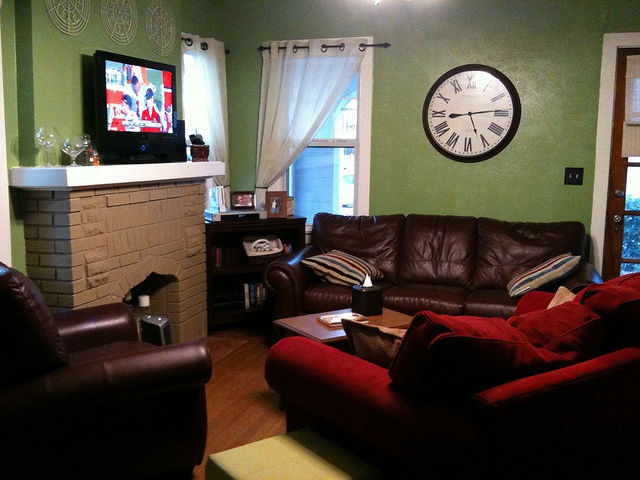Describe the objects in this image and their specific colors. I can see couch in gray, black, maroon, and brown tones, couch in gray, black, maroon, and brown tones, chair in gray, black, maroon, and brown tones, couch in gray, black, and maroon tones, and tv in gray, black, white, lightblue, and salmon tones in this image. 